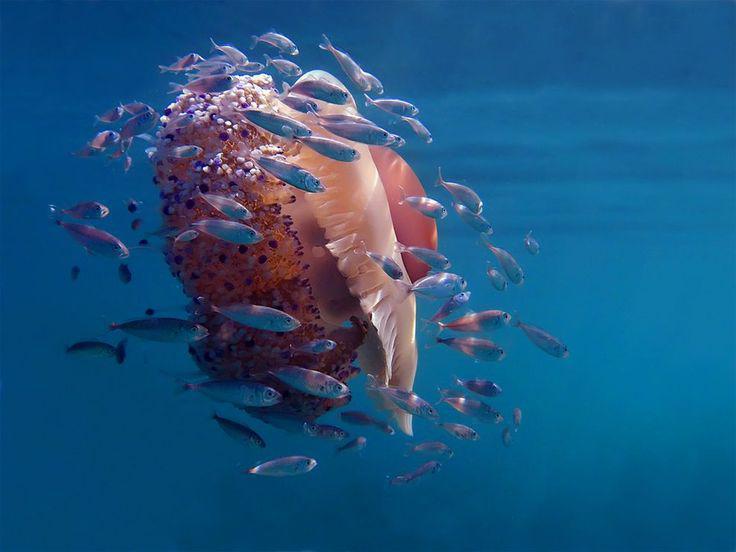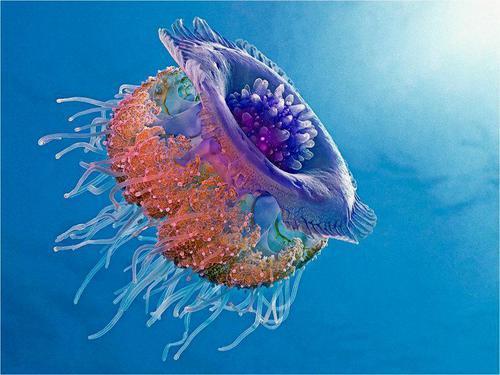The first image is the image on the left, the second image is the image on the right. Evaluate the accuracy of this statement regarding the images: "There are at least two small fish swimming near the jellyfish in one of the images.". Is it true? Answer yes or no. Yes. 